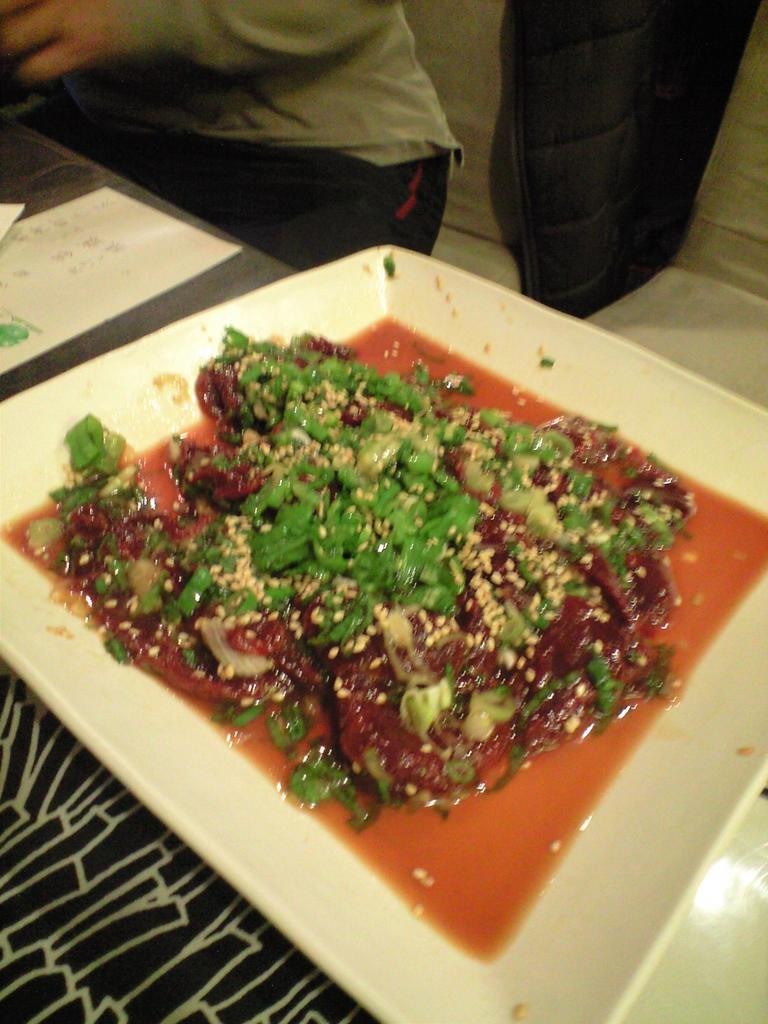What is the main piece of furniture in the image? There is a table in the image. What is on the table? There is a bowl on the table. What is in the bowl? The bowl contains soup. What type of ingredients are in the soup? The soup has vegetables in it. What else is in the bowl? There is a vegetable salad in the bowl. Who is present in the image? There is a person sitting behind the table. How much money does the person have in their pocket in the image? There is no information about the person's pocket or any money in the image. 